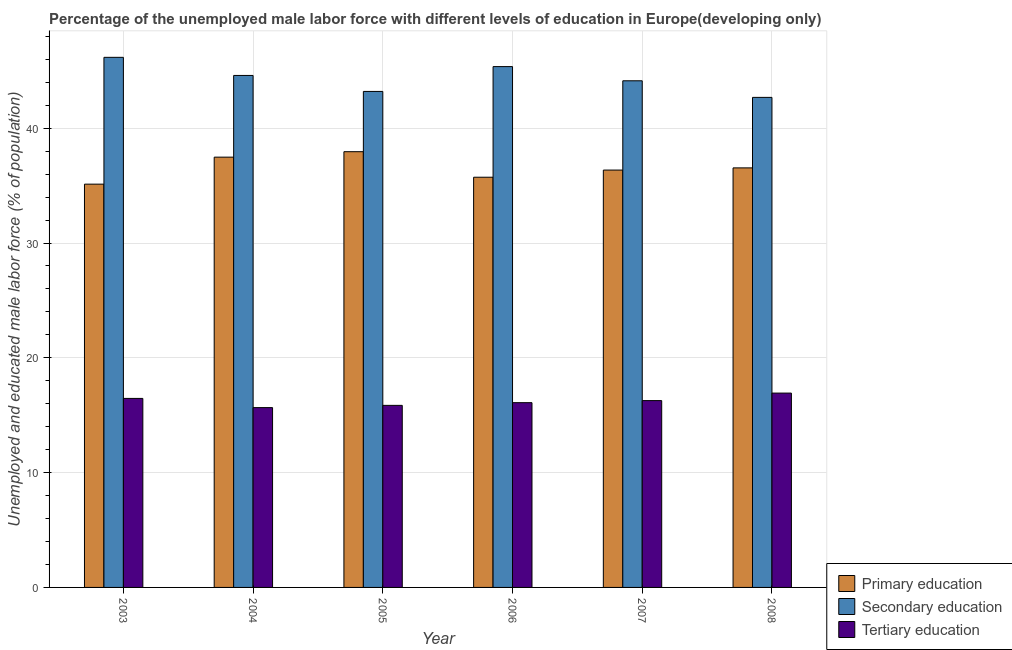How many different coloured bars are there?
Your response must be concise. 3. How many groups of bars are there?
Make the answer very short. 6. Are the number of bars on each tick of the X-axis equal?
Your response must be concise. Yes. How many bars are there on the 2nd tick from the right?
Ensure brevity in your answer.  3. What is the percentage of male labor force who received secondary education in 2007?
Offer a terse response. 44.13. Across all years, what is the maximum percentage of male labor force who received tertiary education?
Offer a terse response. 16.93. Across all years, what is the minimum percentage of male labor force who received tertiary education?
Offer a terse response. 15.66. In which year was the percentage of male labor force who received secondary education maximum?
Keep it short and to the point. 2003. What is the total percentage of male labor force who received tertiary education in the graph?
Make the answer very short. 97.29. What is the difference between the percentage of male labor force who received tertiary education in 2005 and that in 2008?
Make the answer very short. -1.07. What is the difference between the percentage of male labor force who received secondary education in 2008 and the percentage of male labor force who received primary education in 2005?
Provide a short and direct response. -0.52. What is the average percentage of male labor force who received primary education per year?
Your response must be concise. 36.53. What is the ratio of the percentage of male labor force who received tertiary education in 2007 to that in 2008?
Make the answer very short. 0.96. What is the difference between the highest and the second highest percentage of male labor force who received primary education?
Provide a short and direct response. 0.47. What is the difference between the highest and the lowest percentage of male labor force who received secondary education?
Give a very brief answer. 3.49. What does the 2nd bar from the right in 2005 represents?
Offer a terse response. Secondary education. Is it the case that in every year, the sum of the percentage of male labor force who received primary education and percentage of male labor force who received secondary education is greater than the percentage of male labor force who received tertiary education?
Ensure brevity in your answer.  Yes. How many bars are there?
Offer a terse response. 18. How many years are there in the graph?
Provide a short and direct response. 6. Does the graph contain any zero values?
Keep it short and to the point. No. How are the legend labels stacked?
Offer a very short reply. Vertical. What is the title of the graph?
Your answer should be compact. Percentage of the unemployed male labor force with different levels of education in Europe(developing only). What is the label or title of the Y-axis?
Ensure brevity in your answer.  Unemployed and educated male labor force (% of population). What is the Unemployed and educated male labor force (% of population) in Primary education in 2003?
Provide a succinct answer. 35.13. What is the Unemployed and educated male labor force (% of population) in Secondary education in 2003?
Provide a short and direct response. 46.18. What is the Unemployed and educated male labor force (% of population) of Tertiary education in 2003?
Keep it short and to the point. 16.46. What is the Unemployed and educated male labor force (% of population) of Primary education in 2004?
Your response must be concise. 37.48. What is the Unemployed and educated male labor force (% of population) in Secondary education in 2004?
Offer a terse response. 44.6. What is the Unemployed and educated male labor force (% of population) of Tertiary education in 2004?
Offer a terse response. 15.66. What is the Unemployed and educated male labor force (% of population) of Primary education in 2005?
Provide a succinct answer. 37.96. What is the Unemployed and educated male labor force (% of population) of Secondary education in 2005?
Provide a succinct answer. 43.21. What is the Unemployed and educated male labor force (% of population) of Tertiary education in 2005?
Make the answer very short. 15.86. What is the Unemployed and educated male labor force (% of population) in Primary education in 2006?
Keep it short and to the point. 35.73. What is the Unemployed and educated male labor force (% of population) in Secondary education in 2006?
Make the answer very short. 45.37. What is the Unemployed and educated male labor force (% of population) in Tertiary education in 2006?
Offer a terse response. 16.1. What is the Unemployed and educated male labor force (% of population) in Primary education in 2007?
Provide a succinct answer. 36.36. What is the Unemployed and educated male labor force (% of population) in Secondary education in 2007?
Offer a terse response. 44.13. What is the Unemployed and educated male labor force (% of population) in Tertiary education in 2007?
Ensure brevity in your answer.  16.27. What is the Unemployed and educated male labor force (% of population) in Primary education in 2008?
Offer a very short reply. 36.55. What is the Unemployed and educated male labor force (% of population) in Secondary education in 2008?
Your answer should be compact. 42.69. What is the Unemployed and educated male labor force (% of population) of Tertiary education in 2008?
Offer a terse response. 16.93. Across all years, what is the maximum Unemployed and educated male labor force (% of population) in Primary education?
Ensure brevity in your answer.  37.96. Across all years, what is the maximum Unemployed and educated male labor force (% of population) of Secondary education?
Offer a very short reply. 46.18. Across all years, what is the maximum Unemployed and educated male labor force (% of population) of Tertiary education?
Offer a very short reply. 16.93. Across all years, what is the minimum Unemployed and educated male labor force (% of population) in Primary education?
Ensure brevity in your answer.  35.13. Across all years, what is the minimum Unemployed and educated male labor force (% of population) in Secondary education?
Ensure brevity in your answer.  42.69. Across all years, what is the minimum Unemployed and educated male labor force (% of population) in Tertiary education?
Give a very brief answer. 15.66. What is the total Unemployed and educated male labor force (% of population) in Primary education in the graph?
Your response must be concise. 219.2. What is the total Unemployed and educated male labor force (% of population) of Secondary education in the graph?
Your response must be concise. 266.17. What is the total Unemployed and educated male labor force (% of population) of Tertiary education in the graph?
Make the answer very short. 97.29. What is the difference between the Unemployed and educated male labor force (% of population) in Primary education in 2003 and that in 2004?
Make the answer very short. -2.35. What is the difference between the Unemployed and educated male labor force (% of population) in Secondary education in 2003 and that in 2004?
Keep it short and to the point. 1.58. What is the difference between the Unemployed and educated male labor force (% of population) of Tertiary education in 2003 and that in 2004?
Give a very brief answer. 0.8. What is the difference between the Unemployed and educated male labor force (% of population) in Primary education in 2003 and that in 2005?
Your answer should be very brief. -2.83. What is the difference between the Unemployed and educated male labor force (% of population) in Secondary education in 2003 and that in 2005?
Give a very brief answer. 2.97. What is the difference between the Unemployed and educated male labor force (% of population) of Tertiary education in 2003 and that in 2005?
Ensure brevity in your answer.  0.61. What is the difference between the Unemployed and educated male labor force (% of population) in Primary education in 2003 and that in 2006?
Offer a terse response. -0.6. What is the difference between the Unemployed and educated male labor force (% of population) in Secondary education in 2003 and that in 2006?
Ensure brevity in your answer.  0.81. What is the difference between the Unemployed and educated male labor force (% of population) of Tertiary education in 2003 and that in 2006?
Keep it short and to the point. 0.37. What is the difference between the Unemployed and educated male labor force (% of population) of Primary education in 2003 and that in 2007?
Offer a very short reply. -1.23. What is the difference between the Unemployed and educated male labor force (% of population) of Secondary education in 2003 and that in 2007?
Your answer should be compact. 2.04. What is the difference between the Unemployed and educated male labor force (% of population) of Tertiary education in 2003 and that in 2007?
Your response must be concise. 0.19. What is the difference between the Unemployed and educated male labor force (% of population) of Primary education in 2003 and that in 2008?
Make the answer very short. -1.42. What is the difference between the Unemployed and educated male labor force (% of population) of Secondary education in 2003 and that in 2008?
Ensure brevity in your answer.  3.49. What is the difference between the Unemployed and educated male labor force (% of population) in Tertiary education in 2003 and that in 2008?
Your answer should be compact. -0.46. What is the difference between the Unemployed and educated male labor force (% of population) of Primary education in 2004 and that in 2005?
Your response must be concise. -0.47. What is the difference between the Unemployed and educated male labor force (% of population) in Secondary education in 2004 and that in 2005?
Make the answer very short. 1.39. What is the difference between the Unemployed and educated male labor force (% of population) of Tertiary education in 2004 and that in 2005?
Offer a terse response. -0.2. What is the difference between the Unemployed and educated male labor force (% of population) of Primary education in 2004 and that in 2006?
Offer a terse response. 1.75. What is the difference between the Unemployed and educated male labor force (% of population) of Secondary education in 2004 and that in 2006?
Offer a very short reply. -0.77. What is the difference between the Unemployed and educated male labor force (% of population) in Tertiary education in 2004 and that in 2006?
Your answer should be compact. -0.43. What is the difference between the Unemployed and educated male labor force (% of population) in Primary education in 2004 and that in 2007?
Give a very brief answer. 1.13. What is the difference between the Unemployed and educated male labor force (% of population) in Secondary education in 2004 and that in 2007?
Your answer should be very brief. 0.47. What is the difference between the Unemployed and educated male labor force (% of population) of Tertiary education in 2004 and that in 2007?
Offer a very short reply. -0.61. What is the difference between the Unemployed and educated male labor force (% of population) of Primary education in 2004 and that in 2008?
Give a very brief answer. 0.94. What is the difference between the Unemployed and educated male labor force (% of population) of Secondary education in 2004 and that in 2008?
Your response must be concise. 1.91. What is the difference between the Unemployed and educated male labor force (% of population) in Tertiary education in 2004 and that in 2008?
Give a very brief answer. -1.27. What is the difference between the Unemployed and educated male labor force (% of population) of Primary education in 2005 and that in 2006?
Give a very brief answer. 2.22. What is the difference between the Unemployed and educated male labor force (% of population) in Secondary education in 2005 and that in 2006?
Your answer should be very brief. -2.16. What is the difference between the Unemployed and educated male labor force (% of population) in Tertiary education in 2005 and that in 2006?
Offer a very short reply. -0.24. What is the difference between the Unemployed and educated male labor force (% of population) of Primary education in 2005 and that in 2007?
Give a very brief answer. 1.6. What is the difference between the Unemployed and educated male labor force (% of population) in Secondary education in 2005 and that in 2007?
Give a very brief answer. -0.93. What is the difference between the Unemployed and educated male labor force (% of population) in Tertiary education in 2005 and that in 2007?
Provide a short and direct response. -0.42. What is the difference between the Unemployed and educated male labor force (% of population) in Primary education in 2005 and that in 2008?
Keep it short and to the point. 1.41. What is the difference between the Unemployed and educated male labor force (% of population) of Secondary education in 2005 and that in 2008?
Ensure brevity in your answer.  0.52. What is the difference between the Unemployed and educated male labor force (% of population) of Tertiary education in 2005 and that in 2008?
Provide a short and direct response. -1.07. What is the difference between the Unemployed and educated male labor force (% of population) in Primary education in 2006 and that in 2007?
Offer a very short reply. -0.62. What is the difference between the Unemployed and educated male labor force (% of population) of Secondary education in 2006 and that in 2007?
Your answer should be compact. 1.24. What is the difference between the Unemployed and educated male labor force (% of population) in Tertiary education in 2006 and that in 2007?
Make the answer very short. -0.18. What is the difference between the Unemployed and educated male labor force (% of population) in Primary education in 2006 and that in 2008?
Provide a succinct answer. -0.81. What is the difference between the Unemployed and educated male labor force (% of population) in Secondary education in 2006 and that in 2008?
Offer a terse response. 2.68. What is the difference between the Unemployed and educated male labor force (% of population) in Tertiary education in 2006 and that in 2008?
Provide a succinct answer. -0.83. What is the difference between the Unemployed and educated male labor force (% of population) in Primary education in 2007 and that in 2008?
Your response must be concise. -0.19. What is the difference between the Unemployed and educated male labor force (% of population) in Secondary education in 2007 and that in 2008?
Make the answer very short. 1.45. What is the difference between the Unemployed and educated male labor force (% of population) of Tertiary education in 2007 and that in 2008?
Make the answer very short. -0.65. What is the difference between the Unemployed and educated male labor force (% of population) of Primary education in 2003 and the Unemployed and educated male labor force (% of population) of Secondary education in 2004?
Your answer should be compact. -9.47. What is the difference between the Unemployed and educated male labor force (% of population) of Primary education in 2003 and the Unemployed and educated male labor force (% of population) of Tertiary education in 2004?
Ensure brevity in your answer.  19.47. What is the difference between the Unemployed and educated male labor force (% of population) of Secondary education in 2003 and the Unemployed and educated male labor force (% of population) of Tertiary education in 2004?
Your answer should be very brief. 30.51. What is the difference between the Unemployed and educated male labor force (% of population) in Primary education in 2003 and the Unemployed and educated male labor force (% of population) in Secondary education in 2005?
Your answer should be very brief. -8.08. What is the difference between the Unemployed and educated male labor force (% of population) in Primary education in 2003 and the Unemployed and educated male labor force (% of population) in Tertiary education in 2005?
Provide a short and direct response. 19.27. What is the difference between the Unemployed and educated male labor force (% of population) in Secondary education in 2003 and the Unemployed and educated male labor force (% of population) in Tertiary education in 2005?
Offer a terse response. 30.32. What is the difference between the Unemployed and educated male labor force (% of population) in Primary education in 2003 and the Unemployed and educated male labor force (% of population) in Secondary education in 2006?
Your answer should be very brief. -10.24. What is the difference between the Unemployed and educated male labor force (% of population) of Primary education in 2003 and the Unemployed and educated male labor force (% of population) of Tertiary education in 2006?
Your answer should be very brief. 19.03. What is the difference between the Unemployed and educated male labor force (% of population) of Secondary education in 2003 and the Unemployed and educated male labor force (% of population) of Tertiary education in 2006?
Provide a short and direct response. 30.08. What is the difference between the Unemployed and educated male labor force (% of population) in Primary education in 2003 and the Unemployed and educated male labor force (% of population) in Secondary education in 2007?
Give a very brief answer. -9. What is the difference between the Unemployed and educated male labor force (% of population) in Primary education in 2003 and the Unemployed and educated male labor force (% of population) in Tertiary education in 2007?
Ensure brevity in your answer.  18.86. What is the difference between the Unemployed and educated male labor force (% of population) in Secondary education in 2003 and the Unemployed and educated male labor force (% of population) in Tertiary education in 2007?
Provide a short and direct response. 29.9. What is the difference between the Unemployed and educated male labor force (% of population) of Primary education in 2003 and the Unemployed and educated male labor force (% of population) of Secondary education in 2008?
Provide a short and direct response. -7.56. What is the difference between the Unemployed and educated male labor force (% of population) in Primary education in 2003 and the Unemployed and educated male labor force (% of population) in Tertiary education in 2008?
Offer a very short reply. 18.2. What is the difference between the Unemployed and educated male labor force (% of population) of Secondary education in 2003 and the Unemployed and educated male labor force (% of population) of Tertiary education in 2008?
Your answer should be compact. 29.25. What is the difference between the Unemployed and educated male labor force (% of population) in Primary education in 2004 and the Unemployed and educated male labor force (% of population) in Secondary education in 2005?
Give a very brief answer. -5.72. What is the difference between the Unemployed and educated male labor force (% of population) in Primary education in 2004 and the Unemployed and educated male labor force (% of population) in Tertiary education in 2005?
Offer a terse response. 21.62. What is the difference between the Unemployed and educated male labor force (% of population) in Secondary education in 2004 and the Unemployed and educated male labor force (% of population) in Tertiary education in 2005?
Keep it short and to the point. 28.74. What is the difference between the Unemployed and educated male labor force (% of population) in Primary education in 2004 and the Unemployed and educated male labor force (% of population) in Secondary education in 2006?
Your response must be concise. -7.89. What is the difference between the Unemployed and educated male labor force (% of population) in Primary education in 2004 and the Unemployed and educated male labor force (% of population) in Tertiary education in 2006?
Make the answer very short. 21.39. What is the difference between the Unemployed and educated male labor force (% of population) in Secondary education in 2004 and the Unemployed and educated male labor force (% of population) in Tertiary education in 2006?
Your answer should be compact. 28.5. What is the difference between the Unemployed and educated male labor force (% of population) of Primary education in 2004 and the Unemployed and educated male labor force (% of population) of Secondary education in 2007?
Your response must be concise. -6.65. What is the difference between the Unemployed and educated male labor force (% of population) of Primary education in 2004 and the Unemployed and educated male labor force (% of population) of Tertiary education in 2007?
Ensure brevity in your answer.  21.21. What is the difference between the Unemployed and educated male labor force (% of population) in Secondary education in 2004 and the Unemployed and educated male labor force (% of population) in Tertiary education in 2007?
Provide a short and direct response. 28.32. What is the difference between the Unemployed and educated male labor force (% of population) in Primary education in 2004 and the Unemployed and educated male labor force (% of population) in Secondary education in 2008?
Keep it short and to the point. -5.21. What is the difference between the Unemployed and educated male labor force (% of population) in Primary education in 2004 and the Unemployed and educated male labor force (% of population) in Tertiary education in 2008?
Offer a terse response. 20.55. What is the difference between the Unemployed and educated male labor force (% of population) in Secondary education in 2004 and the Unemployed and educated male labor force (% of population) in Tertiary education in 2008?
Give a very brief answer. 27.67. What is the difference between the Unemployed and educated male labor force (% of population) of Primary education in 2005 and the Unemployed and educated male labor force (% of population) of Secondary education in 2006?
Keep it short and to the point. -7.41. What is the difference between the Unemployed and educated male labor force (% of population) in Primary education in 2005 and the Unemployed and educated male labor force (% of population) in Tertiary education in 2006?
Your answer should be very brief. 21.86. What is the difference between the Unemployed and educated male labor force (% of population) of Secondary education in 2005 and the Unemployed and educated male labor force (% of population) of Tertiary education in 2006?
Offer a very short reply. 27.11. What is the difference between the Unemployed and educated male labor force (% of population) of Primary education in 2005 and the Unemployed and educated male labor force (% of population) of Secondary education in 2007?
Keep it short and to the point. -6.18. What is the difference between the Unemployed and educated male labor force (% of population) in Primary education in 2005 and the Unemployed and educated male labor force (% of population) in Tertiary education in 2007?
Offer a terse response. 21.68. What is the difference between the Unemployed and educated male labor force (% of population) of Secondary education in 2005 and the Unemployed and educated male labor force (% of population) of Tertiary education in 2007?
Your response must be concise. 26.93. What is the difference between the Unemployed and educated male labor force (% of population) of Primary education in 2005 and the Unemployed and educated male labor force (% of population) of Secondary education in 2008?
Provide a short and direct response. -4.73. What is the difference between the Unemployed and educated male labor force (% of population) in Primary education in 2005 and the Unemployed and educated male labor force (% of population) in Tertiary education in 2008?
Offer a very short reply. 21.03. What is the difference between the Unemployed and educated male labor force (% of population) of Secondary education in 2005 and the Unemployed and educated male labor force (% of population) of Tertiary education in 2008?
Your response must be concise. 26.28. What is the difference between the Unemployed and educated male labor force (% of population) of Primary education in 2006 and the Unemployed and educated male labor force (% of population) of Secondary education in 2007?
Your answer should be very brief. -8.4. What is the difference between the Unemployed and educated male labor force (% of population) in Primary education in 2006 and the Unemployed and educated male labor force (% of population) in Tertiary education in 2007?
Ensure brevity in your answer.  19.46. What is the difference between the Unemployed and educated male labor force (% of population) in Secondary education in 2006 and the Unemployed and educated male labor force (% of population) in Tertiary education in 2007?
Ensure brevity in your answer.  29.1. What is the difference between the Unemployed and educated male labor force (% of population) of Primary education in 2006 and the Unemployed and educated male labor force (% of population) of Secondary education in 2008?
Keep it short and to the point. -6.96. What is the difference between the Unemployed and educated male labor force (% of population) of Primary education in 2006 and the Unemployed and educated male labor force (% of population) of Tertiary education in 2008?
Give a very brief answer. 18.8. What is the difference between the Unemployed and educated male labor force (% of population) in Secondary education in 2006 and the Unemployed and educated male labor force (% of population) in Tertiary education in 2008?
Offer a terse response. 28.44. What is the difference between the Unemployed and educated male labor force (% of population) of Primary education in 2007 and the Unemployed and educated male labor force (% of population) of Secondary education in 2008?
Offer a very short reply. -6.33. What is the difference between the Unemployed and educated male labor force (% of population) in Primary education in 2007 and the Unemployed and educated male labor force (% of population) in Tertiary education in 2008?
Your response must be concise. 19.43. What is the difference between the Unemployed and educated male labor force (% of population) of Secondary education in 2007 and the Unemployed and educated male labor force (% of population) of Tertiary education in 2008?
Offer a terse response. 27.2. What is the average Unemployed and educated male labor force (% of population) of Primary education per year?
Your response must be concise. 36.53. What is the average Unemployed and educated male labor force (% of population) in Secondary education per year?
Ensure brevity in your answer.  44.36. What is the average Unemployed and educated male labor force (% of population) in Tertiary education per year?
Give a very brief answer. 16.21. In the year 2003, what is the difference between the Unemployed and educated male labor force (% of population) of Primary education and Unemployed and educated male labor force (% of population) of Secondary education?
Give a very brief answer. -11.05. In the year 2003, what is the difference between the Unemployed and educated male labor force (% of population) in Primary education and Unemployed and educated male labor force (% of population) in Tertiary education?
Make the answer very short. 18.66. In the year 2003, what is the difference between the Unemployed and educated male labor force (% of population) in Secondary education and Unemployed and educated male labor force (% of population) in Tertiary education?
Make the answer very short. 29.71. In the year 2004, what is the difference between the Unemployed and educated male labor force (% of population) in Primary education and Unemployed and educated male labor force (% of population) in Secondary education?
Ensure brevity in your answer.  -7.12. In the year 2004, what is the difference between the Unemployed and educated male labor force (% of population) in Primary education and Unemployed and educated male labor force (% of population) in Tertiary education?
Your response must be concise. 21.82. In the year 2004, what is the difference between the Unemployed and educated male labor force (% of population) in Secondary education and Unemployed and educated male labor force (% of population) in Tertiary education?
Make the answer very short. 28.94. In the year 2005, what is the difference between the Unemployed and educated male labor force (% of population) of Primary education and Unemployed and educated male labor force (% of population) of Secondary education?
Make the answer very short. -5.25. In the year 2005, what is the difference between the Unemployed and educated male labor force (% of population) in Primary education and Unemployed and educated male labor force (% of population) in Tertiary education?
Your answer should be compact. 22.1. In the year 2005, what is the difference between the Unemployed and educated male labor force (% of population) in Secondary education and Unemployed and educated male labor force (% of population) in Tertiary education?
Keep it short and to the point. 27.35. In the year 2006, what is the difference between the Unemployed and educated male labor force (% of population) of Primary education and Unemployed and educated male labor force (% of population) of Secondary education?
Keep it short and to the point. -9.64. In the year 2006, what is the difference between the Unemployed and educated male labor force (% of population) in Primary education and Unemployed and educated male labor force (% of population) in Tertiary education?
Make the answer very short. 19.64. In the year 2006, what is the difference between the Unemployed and educated male labor force (% of population) in Secondary education and Unemployed and educated male labor force (% of population) in Tertiary education?
Your answer should be compact. 29.27. In the year 2007, what is the difference between the Unemployed and educated male labor force (% of population) in Primary education and Unemployed and educated male labor force (% of population) in Secondary education?
Keep it short and to the point. -7.78. In the year 2007, what is the difference between the Unemployed and educated male labor force (% of population) in Primary education and Unemployed and educated male labor force (% of population) in Tertiary education?
Offer a very short reply. 20.08. In the year 2007, what is the difference between the Unemployed and educated male labor force (% of population) of Secondary education and Unemployed and educated male labor force (% of population) of Tertiary education?
Provide a succinct answer. 27.86. In the year 2008, what is the difference between the Unemployed and educated male labor force (% of population) of Primary education and Unemployed and educated male labor force (% of population) of Secondary education?
Your answer should be very brief. -6.14. In the year 2008, what is the difference between the Unemployed and educated male labor force (% of population) in Primary education and Unemployed and educated male labor force (% of population) in Tertiary education?
Offer a terse response. 19.62. In the year 2008, what is the difference between the Unemployed and educated male labor force (% of population) in Secondary education and Unemployed and educated male labor force (% of population) in Tertiary education?
Your answer should be compact. 25.76. What is the ratio of the Unemployed and educated male labor force (% of population) in Primary education in 2003 to that in 2004?
Offer a terse response. 0.94. What is the ratio of the Unemployed and educated male labor force (% of population) in Secondary education in 2003 to that in 2004?
Provide a short and direct response. 1.04. What is the ratio of the Unemployed and educated male labor force (% of population) of Tertiary education in 2003 to that in 2004?
Offer a terse response. 1.05. What is the ratio of the Unemployed and educated male labor force (% of population) in Primary education in 2003 to that in 2005?
Your answer should be compact. 0.93. What is the ratio of the Unemployed and educated male labor force (% of population) in Secondary education in 2003 to that in 2005?
Offer a very short reply. 1.07. What is the ratio of the Unemployed and educated male labor force (% of population) in Tertiary education in 2003 to that in 2005?
Give a very brief answer. 1.04. What is the ratio of the Unemployed and educated male labor force (% of population) of Primary education in 2003 to that in 2006?
Your answer should be compact. 0.98. What is the ratio of the Unemployed and educated male labor force (% of population) in Secondary education in 2003 to that in 2006?
Your answer should be compact. 1.02. What is the ratio of the Unemployed and educated male labor force (% of population) in Tertiary education in 2003 to that in 2006?
Provide a succinct answer. 1.02. What is the ratio of the Unemployed and educated male labor force (% of population) of Primary education in 2003 to that in 2007?
Your answer should be compact. 0.97. What is the ratio of the Unemployed and educated male labor force (% of population) of Secondary education in 2003 to that in 2007?
Provide a short and direct response. 1.05. What is the ratio of the Unemployed and educated male labor force (% of population) of Tertiary education in 2003 to that in 2007?
Your response must be concise. 1.01. What is the ratio of the Unemployed and educated male labor force (% of population) in Primary education in 2003 to that in 2008?
Keep it short and to the point. 0.96. What is the ratio of the Unemployed and educated male labor force (% of population) in Secondary education in 2003 to that in 2008?
Provide a short and direct response. 1.08. What is the ratio of the Unemployed and educated male labor force (% of population) in Tertiary education in 2003 to that in 2008?
Provide a short and direct response. 0.97. What is the ratio of the Unemployed and educated male labor force (% of population) of Primary education in 2004 to that in 2005?
Keep it short and to the point. 0.99. What is the ratio of the Unemployed and educated male labor force (% of population) in Secondary education in 2004 to that in 2005?
Keep it short and to the point. 1.03. What is the ratio of the Unemployed and educated male labor force (% of population) in Primary education in 2004 to that in 2006?
Your response must be concise. 1.05. What is the ratio of the Unemployed and educated male labor force (% of population) of Secondary education in 2004 to that in 2006?
Provide a succinct answer. 0.98. What is the ratio of the Unemployed and educated male labor force (% of population) in Tertiary education in 2004 to that in 2006?
Make the answer very short. 0.97. What is the ratio of the Unemployed and educated male labor force (% of population) in Primary education in 2004 to that in 2007?
Your response must be concise. 1.03. What is the ratio of the Unemployed and educated male labor force (% of population) in Secondary education in 2004 to that in 2007?
Provide a short and direct response. 1.01. What is the ratio of the Unemployed and educated male labor force (% of population) of Tertiary education in 2004 to that in 2007?
Your answer should be compact. 0.96. What is the ratio of the Unemployed and educated male labor force (% of population) of Primary education in 2004 to that in 2008?
Give a very brief answer. 1.03. What is the ratio of the Unemployed and educated male labor force (% of population) of Secondary education in 2004 to that in 2008?
Make the answer very short. 1.04. What is the ratio of the Unemployed and educated male labor force (% of population) in Tertiary education in 2004 to that in 2008?
Provide a short and direct response. 0.93. What is the ratio of the Unemployed and educated male labor force (% of population) of Primary education in 2005 to that in 2006?
Provide a succinct answer. 1.06. What is the ratio of the Unemployed and educated male labor force (% of population) in Secondary education in 2005 to that in 2006?
Make the answer very short. 0.95. What is the ratio of the Unemployed and educated male labor force (% of population) of Primary education in 2005 to that in 2007?
Your answer should be compact. 1.04. What is the ratio of the Unemployed and educated male labor force (% of population) of Secondary education in 2005 to that in 2007?
Your answer should be compact. 0.98. What is the ratio of the Unemployed and educated male labor force (% of population) of Tertiary education in 2005 to that in 2007?
Your response must be concise. 0.97. What is the ratio of the Unemployed and educated male labor force (% of population) of Primary education in 2005 to that in 2008?
Make the answer very short. 1.04. What is the ratio of the Unemployed and educated male labor force (% of population) of Secondary education in 2005 to that in 2008?
Provide a succinct answer. 1.01. What is the ratio of the Unemployed and educated male labor force (% of population) in Tertiary education in 2005 to that in 2008?
Your answer should be very brief. 0.94. What is the ratio of the Unemployed and educated male labor force (% of population) of Primary education in 2006 to that in 2007?
Make the answer very short. 0.98. What is the ratio of the Unemployed and educated male labor force (% of population) in Secondary education in 2006 to that in 2007?
Your response must be concise. 1.03. What is the ratio of the Unemployed and educated male labor force (% of population) in Primary education in 2006 to that in 2008?
Make the answer very short. 0.98. What is the ratio of the Unemployed and educated male labor force (% of population) in Secondary education in 2006 to that in 2008?
Ensure brevity in your answer.  1.06. What is the ratio of the Unemployed and educated male labor force (% of population) in Tertiary education in 2006 to that in 2008?
Make the answer very short. 0.95. What is the ratio of the Unemployed and educated male labor force (% of population) in Primary education in 2007 to that in 2008?
Provide a succinct answer. 0.99. What is the ratio of the Unemployed and educated male labor force (% of population) of Secondary education in 2007 to that in 2008?
Your answer should be very brief. 1.03. What is the ratio of the Unemployed and educated male labor force (% of population) of Tertiary education in 2007 to that in 2008?
Provide a succinct answer. 0.96. What is the difference between the highest and the second highest Unemployed and educated male labor force (% of population) in Primary education?
Keep it short and to the point. 0.47. What is the difference between the highest and the second highest Unemployed and educated male labor force (% of population) in Secondary education?
Offer a very short reply. 0.81. What is the difference between the highest and the second highest Unemployed and educated male labor force (% of population) in Tertiary education?
Your response must be concise. 0.46. What is the difference between the highest and the lowest Unemployed and educated male labor force (% of population) of Primary education?
Offer a terse response. 2.83. What is the difference between the highest and the lowest Unemployed and educated male labor force (% of population) of Secondary education?
Make the answer very short. 3.49. What is the difference between the highest and the lowest Unemployed and educated male labor force (% of population) of Tertiary education?
Your response must be concise. 1.27. 